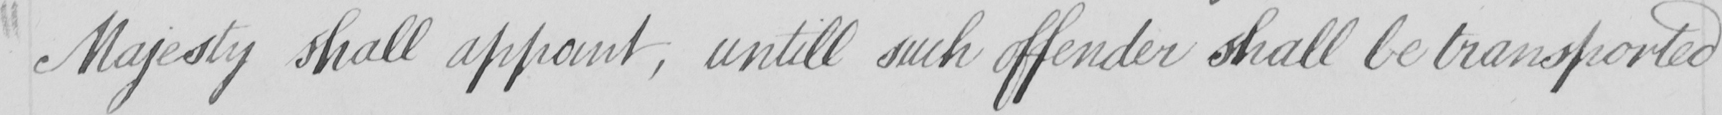Please provide the text content of this handwritten line. Majesty shall appoint , untill such offender shall be transported 